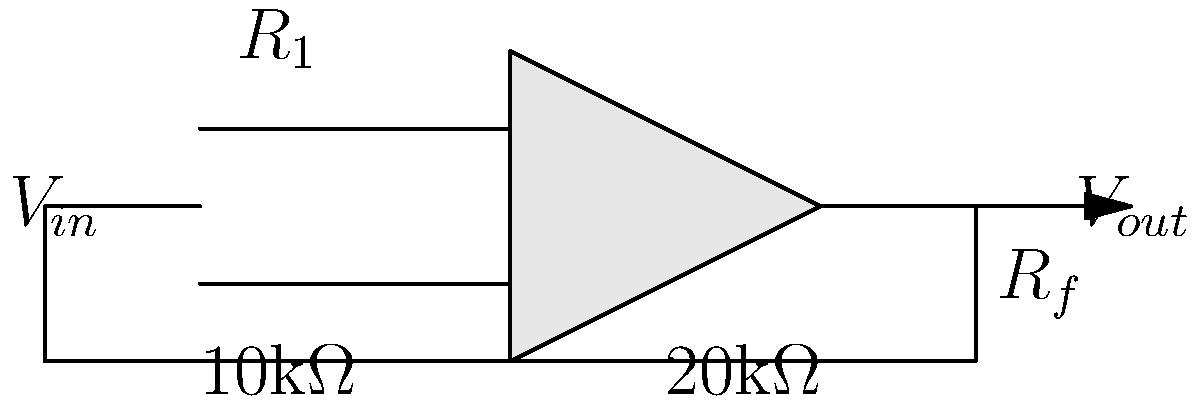Given the inverting operational amplifier circuit shown above, with $R_1 = 10\text{k}\Omega$ and $R_f = 20\text{k}\Omega$, determine the gain of the amplifier. Express your answer as a decimal number. To determine the gain of an inverting operational amplifier circuit, we can follow these steps:

1. Identify the circuit configuration:
   This is an inverting amplifier configuration.

2. Recall the gain formula for an inverting amplifier:
   The gain (A) is given by the formula: $A = -\frac{R_f}{R_1}$

3. Substitute the known values:
   $R_1 = 10\text{k}\Omega$
   $R_f = 20\text{k}\Omega$

4. Calculate the gain:
   $A = -\frac{20\text{k}\Omega}{10\text{k}\Omega} = -2$

5. Express the result as a decimal number:
   The gain is -2, which is already in decimal form.

Note that the negative sign indicates that the output signal is inverted (180° phase shift) relative to the input signal.
Answer: -2 